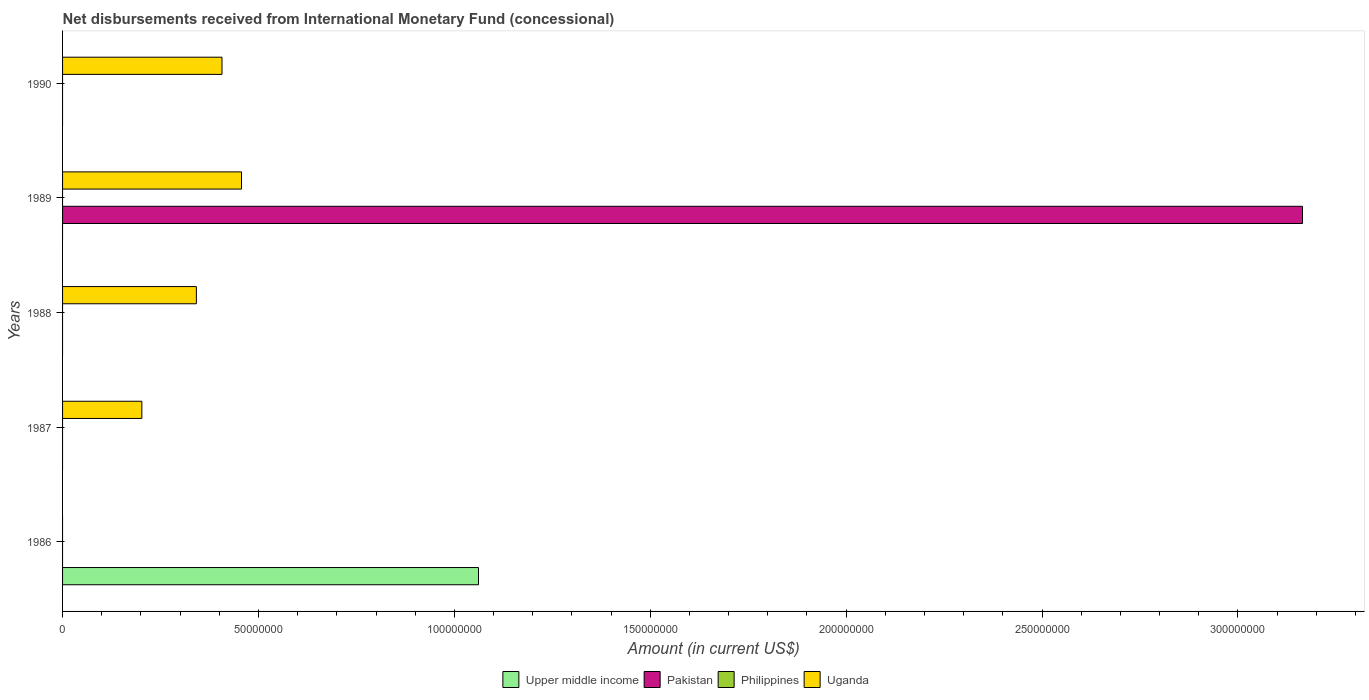How many different coloured bars are there?
Your answer should be compact. 3. Are the number of bars per tick equal to the number of legend labels?
Your answer should be very brief. No. How many bars are there on the 5th tick from the top?
Your answer should be compact. 1. How many bars are there on the 1st tick from the bottom?
Your answer should be very brief. 1. What is the label of the 1st group of bars from the top?
Make the answer very short. 1990. In how many cases, is the number of bars for a given year not equal to the number of legend labels?
Provide a succinct answer. 5. What is the amount of disbursements received from International Monetary Fund in Pakistan in 1986?
Ensure brevity in your answer.  0. Across all years, what is the maximum amount of disbursements received from International Monetary Fund in Pakistan?
Provide a succinct answer. 3.16e+08. In which year was the amount of disbursements received from International Monetary Fund in Upper middle income maximum?
Offer a terse response. 1986. What is the total amount of disbursements received from International Monetary Fund in Upper middle income in the graph?
Make the answer very short. 1.06e+08. What is the difference between the amount of disbursements received from International Monetary Fund in Uganda in 1989 and that in 1990?
Ensure brevity in your answer.  4.98e+06. What is the difference between the amount of disbursements received from International Monetary Fund in Pakistan in 1987 and the amount of disbursements received from International Monetary Fund in Uganda in 1988?
Offer a very short reply. -3.42e+07. What is the average amount of disbursements received from International Monetary Fund in Upper middle income per year?
Keep it short and to the point. 2.12e+07. In the year 1989, what is the difference between the amount of disbursements received from International Monetary Fund in Pakistan and amount of disbursements received from International Monetary Fund in Uganda?
Your answer should be very brief. 2.71e+08. Is the amount of disbursements received from International Monetary Fund in Uganda in 1989 less than that in 1990?
Your answer should be compact. No. What is the difference between the highest and the lowest amount of disbursements received from International Monetary Fund in Pakistan?
Provide a short and direct response. 3.16e+08. Does the graph contain any zero values?
Your answer should be compact. Yes. Does the graph contain grids?
Keep it short and to the point. No. How many legend labels are there?
Keep it short and to the point. 4. What is the title of the graph?
Your answer should be very brief. Net disbursements received from International Monetary Fund (concessional). Does "Belize" appear as one of the legend labels in the graph?
Offer a terse response. No. What is the Amount (in current US$) in Upper middle income in 1986?
Your answer should be compact. 1.06e+08. What is the Amount (in current US$) of Uganda in 1986?
Your answer should be very brief. 0. What is the Amount (in current US$) of Upper middle income in 1987?
Offer a very short reply. 0. What is the Amount (in current US$) in Uganda in 1987?
Provide a succinct answer. 2.02e+07. What is the Amount (in current US$) in Philippines in 1988?
Provide a succinct answer. 0. What is the Amount (in current US$) in Uganda in 1988?
Ensure brevity in your answer.  3.42e+07. What is the Amount (in current US$) in Pakistan in 1989?
Provide a short and direct response. 3.16e+08. What is the Amount (in current US$) in Philippines in 1989?
Your answer should be very brief. 0. What is the Amount (in current US$) in Uganda in 1989?
Keep it short and to the point. 4.57e+07. What is the Amount (in current US$) of Pakistan in 1990?
Give a very brief answer. 0. What is the Amount (in current US$) of Philippines in 1990?
Your response must be concise. 0. What is the Amount (in current US$) of Uganda in 1990?
Give a very brief answer. 4.07e+07. Across all years, what is the maximum Amount (in current US$) in Upper middle income?
Ensure brevity in your answer.  1.06e+08. Across all years, what is the maximum Amount (in current US$) in Pakistan?
Offer a terse response. 3.16e+08. Across all years, what is the maximum Amount (in current US$) in Uganda?
Provide a succinct answer. 4.57e+07. Across all years, what is the minimum Amount (in current US$) of Pakistan?
Your response must be concise. 0. What is the total Amount (in current US$) of Upper middle income in the graph?
Ensure brevity in your answer.  1.06e+08. What is the total Amount (in current US$) of Pakistan in the graph?
Offer a terse response. 3.16e+08. What is the total Amount (in current US$) in Uganda in the graph?
Your response must be concise. 1.41e+08. What is the difference between the Amount (in current US$) of Uganda in 1987 and that in 1988?
Your answer should be compact. -1.39e+07. What is the difference between the Amount (in current US$) in Uganda in 1987 and that in 1989?
Keep it short and to the point. -2.54e+07. What is the difference between the Amount (in current US$) of Uganda in 1987 and that in 1990?
Provide a short and direct response. -2.05e+07. What is the difference between the Amount (in current US$) of Uganda in 1988 and that in 1989?
Offer a terse response. -1.15e+07. What is the difference between the Amount (in current US$) of Uganda in 1988 and that in 1990?
Make the answer very short. -6.54e+06. What is the difference between the Amount (in current US$) in Uganda in 1989 and that in 1990?
Offer a terse response. 4.98e+06. What is the difference between the Amount (in current US$) of Upper middle income in 1986 and the Amount (in current US$) of Uganda in 1987?
Your answer should be compact. 8.59e+07. What is the difference between the Amount (in current US$) in Upper middle income in 1986 and the Amount (in current US$) in Uganda in 1988?
Make the answer very short. 7.20e+07. What is the difference between the Amount (in current US$) in Upper middle income in 1986 and the Amount (in current US$) in Pakistan in 1989?
Offer a very short reply. -2.10e+08. What is the difference between the Amount (in current US$) in Upper middle income in 1986 and the Amount (in current US$) in Uganda in 1989?
Your answer should be very brief. 6.05e+07. What is the difference between the Amount (in current US$) in Upper middle income in 1986 and the Amount (in current US$) in Uganda in 1990?
Give a very brief answer. 6.55e+07. What is the difference between the Amount (in current US$) in Pakistan in 1989 and the Amount (in current US$) in Uganda in 1990?
Your response must be concise. 2.76e+08. What is the average Amount (in current US$) in Upper middle income per year?
Provide a short and direct response. 2.12e+07. What is the average Amount (in current US$) in Pakistan per year?
Give a very brief answer. 6.33e+07. What is the average Amount (in current US$) in Uganda per year?
Provide a short and direct response. 2.82e+07. In the year 1989, what is the difference between the Amount (in current US$) of Pakistan and Amount (in current US$) of Uganda?
Your response must be concise. 2.71e+08. What is the ratio of the Amount (in current US$) of Uganda in 1987 to that in 1988?
Your response must be concise. 0.59. What is the ratio of the Amount (in current US$) of Uganda in 1987 to that in 1989?
Your answer should be compact. 0.44. What is the ratio of the Amount (in current US$) in Uganda in 1987 to that in 1990?
Your answer should be compact. 0.5. What is the ratio of the Amount (in current US$) of Uganda in 1988 to that in 1989?
Provide a succinct answer. 0.75. What is the ratio of the Amount (in current US$) of Uganda in 1988 to that in 1990?
Provide a short and direct response. 0.84. What is the ratio of the Amount (in current US$) in Uganda in 1989 to that in 1990?
Keep it short and to the point. 1.12. What is the difference between the highest and the second highest Amount (in current US$) of Uganda?
Provide a succinct answer. 4.98e+06. What is the difference between the highest and the lowest Amount (in current US$) in Upper middle income?
Provide a short and direct response. 1.06e+08. What is the difference between the highest and the lowest Amount (in current US$) in Pakistan?
Ensure brevity in your answer.  3.16e+08. What is the difference between the highest and the lowest Amount (in current US$) in Uganda?
Your answer should be compact. 4.57e+07. 